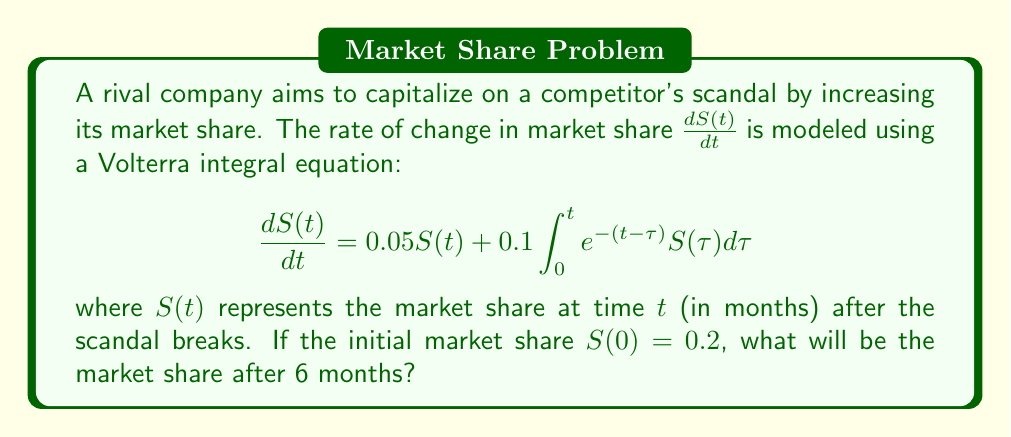Show me your answer to this math problem. To solve this Volterra integral equation, we'll use the Laplace transform method:

1) Take the Laplace transform of both sides:
   $$\mathcal{L}\left\{\frac{dS(t)}{dt}\right\} = 0.05\mathcal{L}\{S(t)\} + 0.1\mathcal{L}\left\{\int_0^t e^{-(t-\tau)}S(\tau)d\tau\right\}$$

2) Using Laplace transform properties:
   $$s\bar{S}(s) - S(0) = 0.05\bar{S}(s) + 0.1\bar{S}(s)\cdot\frac{1}{s+1}$$

3) Substitute $S(0) = 0.2$ and solve for $\bar{S}(s)$:
   $$\bar{S}(s) = \frac{0.2}{s - 0.05 - \frac{0.1}{s+1}}$$

4) Simplify:
   $$\bar{S}(s) = \frac{0.2(s+1)}{s^2 + 0.95s - 0.05}$$

5) Find the inverse Laplace transform:
   $$S(t) = 0.2e^{0.1t} + 0.0952(e^{0.1t} - e^{-1.05t})$$

6) Evaluate at $t = 6$:
   $$S(6) = 0.2e^{0.6} + 0.0952(e^{0.6} - e^{-6.3})$$
   $$S(6) \approx 0.3641$$

Therefore, the market share after 6 months will be approximately 0.3641 or 36.41%.
Answer: 0.3641 